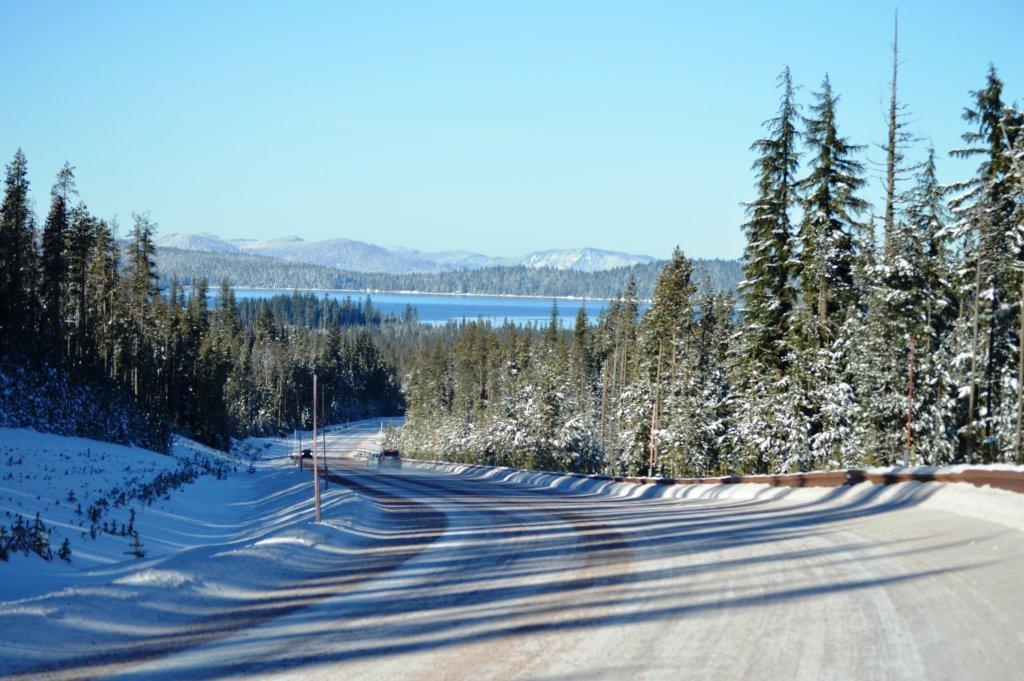What is present on the road in the image? There are vehicles on the road in the image. What can be seen in the background of the image? In the background of the image, there are poles, trees, water, mountains, and the sky. What is the weather like in the image? The presence of snow in the background suggests that it is a snowy scene. What type of leather is being used to make the mind visible in the image? There is no leather or mind present in the image. How many grains of sand can be seen on the road in the image? There is no sand visible on the road in the image. 